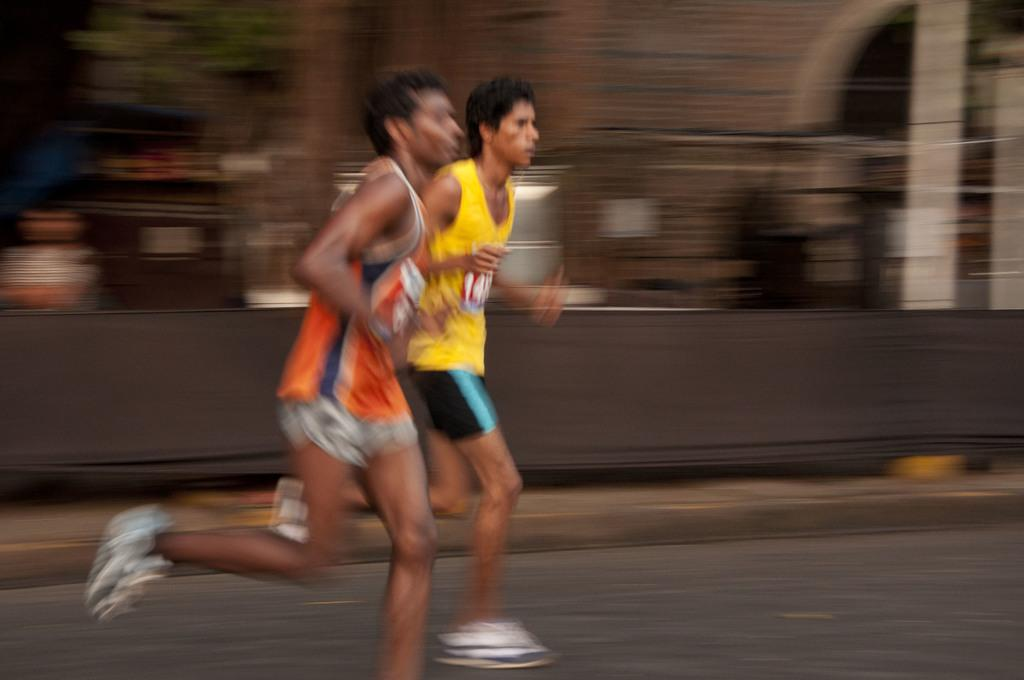How many people are in the image? There are two men in the image. What are the men doing in the image? The men are running on the road. Can you describe the background of the image? The background of the image is blurry. What type of stove can be seen in the image? There is no stove present in the image. How many clovers are visible on the road in the image? There are no clovers visible on the road in the image. 